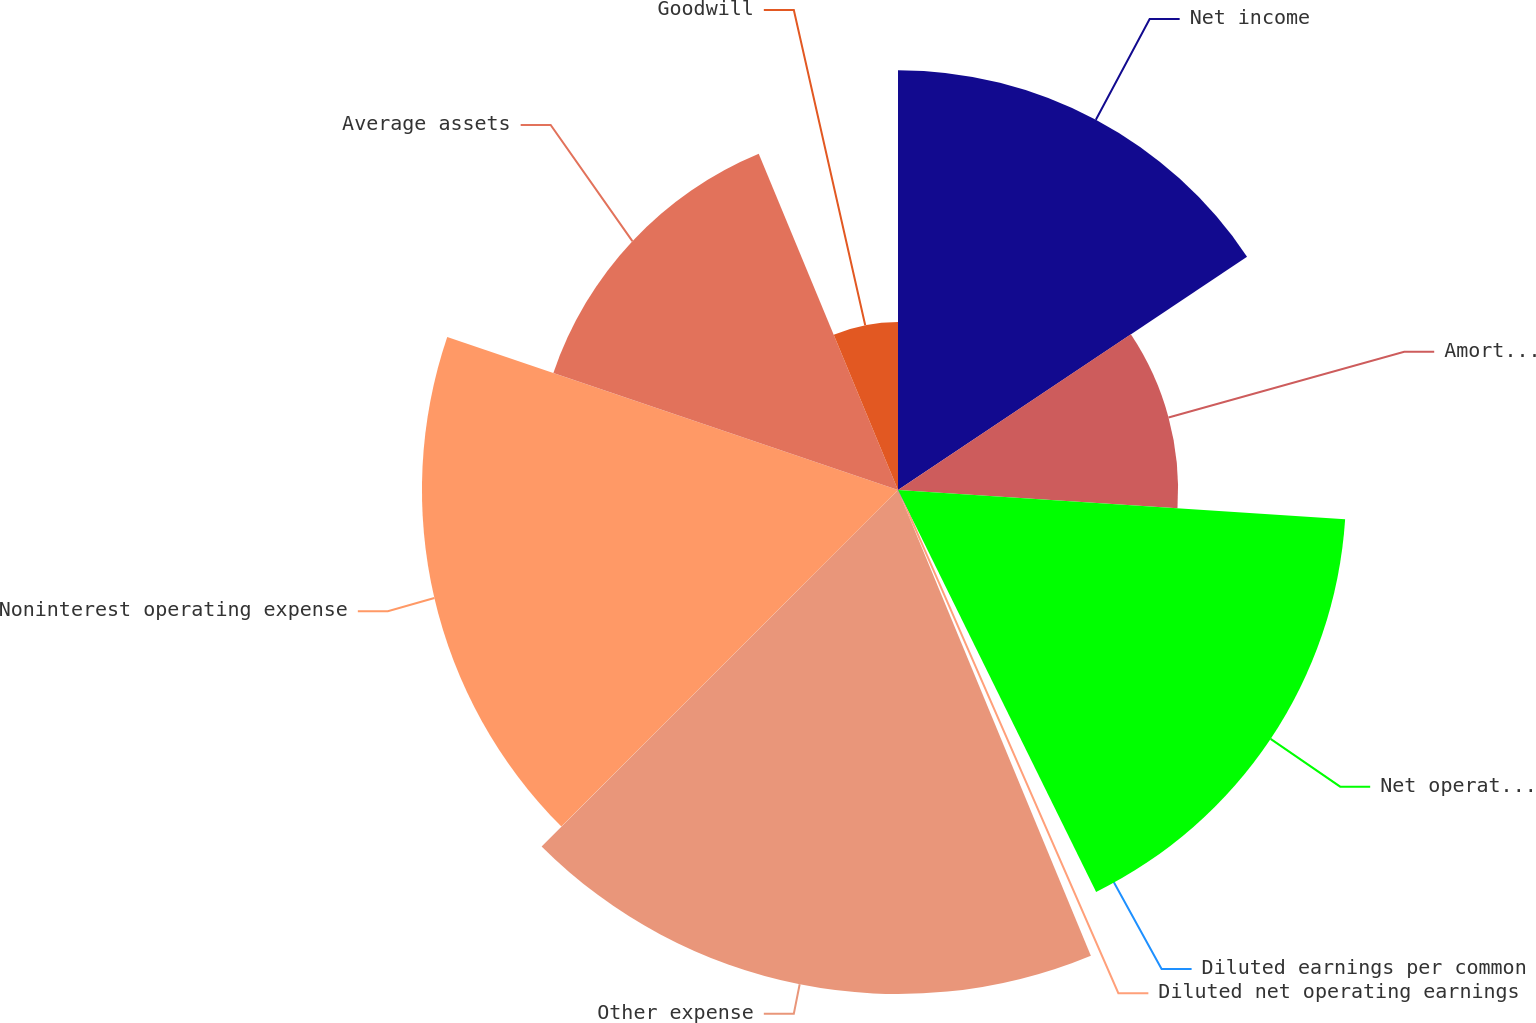Convert chart to OTSL. <chart><loc_0><loc_0><loc_500><loc_500><pie_chart><fcel>Net income<fcel>Amortization of core deposit<fcel>Net operating income<fcel>Diluted earnings per common<fcel>Diluted net operating earnings<fcel>Other expense<fcel>Noninterest operating expense<fcel>Average assets<fcel>Goodwill<nl><fcel>15.62%<fcel>10.42%<fcel>16.67%<fcel>0.0%<fcel>1.04%<fcel>18.75%<fcel>17.71%<fcel>13.54%<fcel>6.25%<nl></chart> 